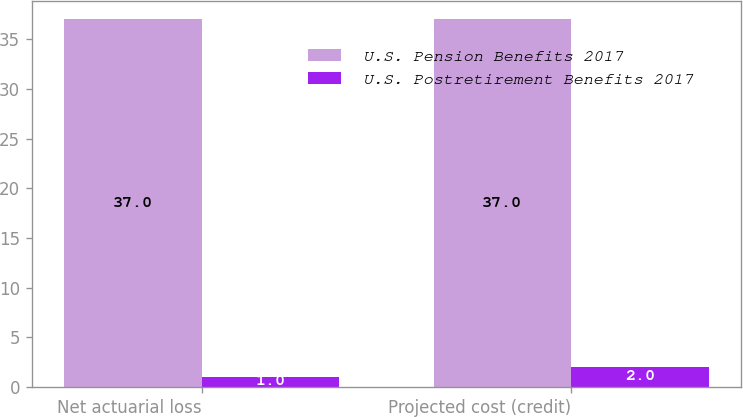Convert chart. <chart><loc_0><loc_0><loc_500><loc_500><stacked_bar_chart><ecel><fcel>Net actuarial loss<fcel>Projected cost (credit)<nl><fcel>U.S. Pension Benefits 2017<fcel>37<fcel>37<nl><fcel>U.S. Postretirement Benefits 2017<fcel>1<fcel>2<nl></chart> 